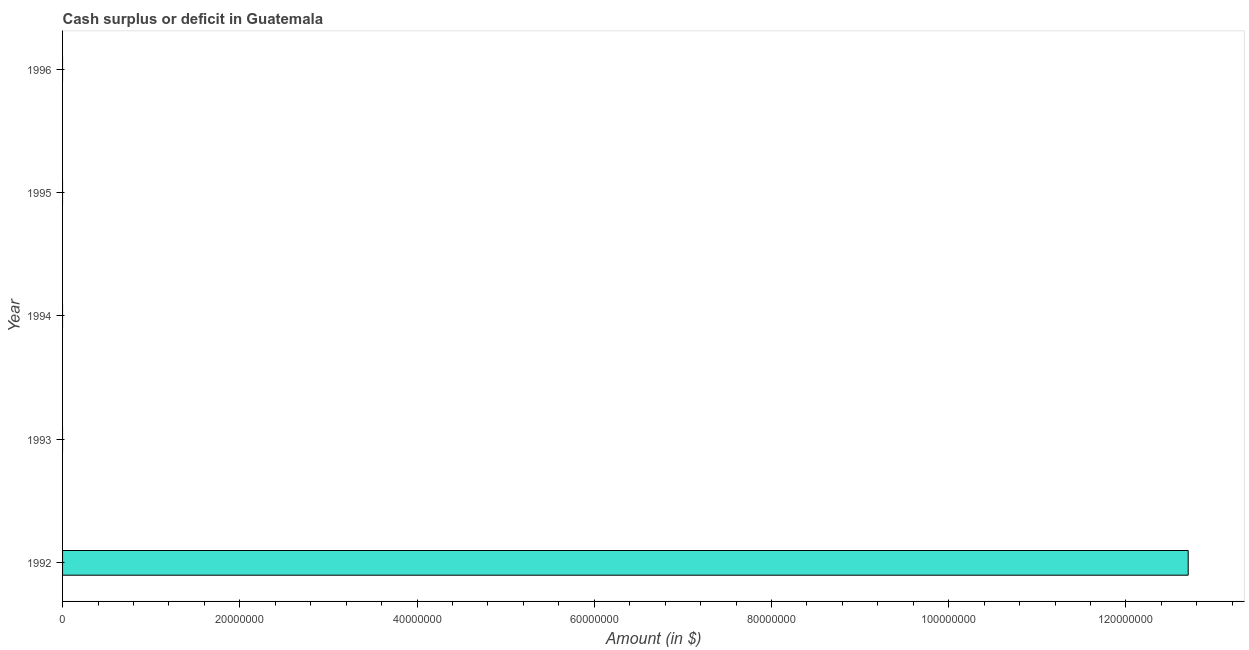Does the graph contain grids?
Provide a succinct answer. No. What is the title of the graph?
Offer a very short reply. Cash surplus or deficit in Guatemala. What is the label or title of the X-axis?
Offer a terse response. Amount (in $). What is the label or title of the Y-axis?
Your answer should be very brief. Year. What is the cash surplus or deficit in 1992?
Keep it short and to the point. 1.27e+08. Across all years, what is the maximum cash surplus or deficit?
Offer a very short reply. 1.27e+08. In which year was the cash surplus or deficit maximum?
Your answer should be very brief. 1992. What is the sum of the cash surplus or deficit?
Give a very brief answer. 1.27e+08. What is the average cash surplus or deficit per year?
Ensure brevity in your answer.  2.54e+07. What is the median cash surplus or deficit?
Your answer should be very brief. 0. What is the difference between the highest and the lowest cash surplus or deficit?
Provide a short and direct response. 1.27e+08. In how many years, is the cash surplus or deficit greater than the average cash surplus or deficit taken over all years?
Keep it short and to the point. 1. What is the Amount (in $) in 1992?
Offer a very short reply. 1.27e+08. 